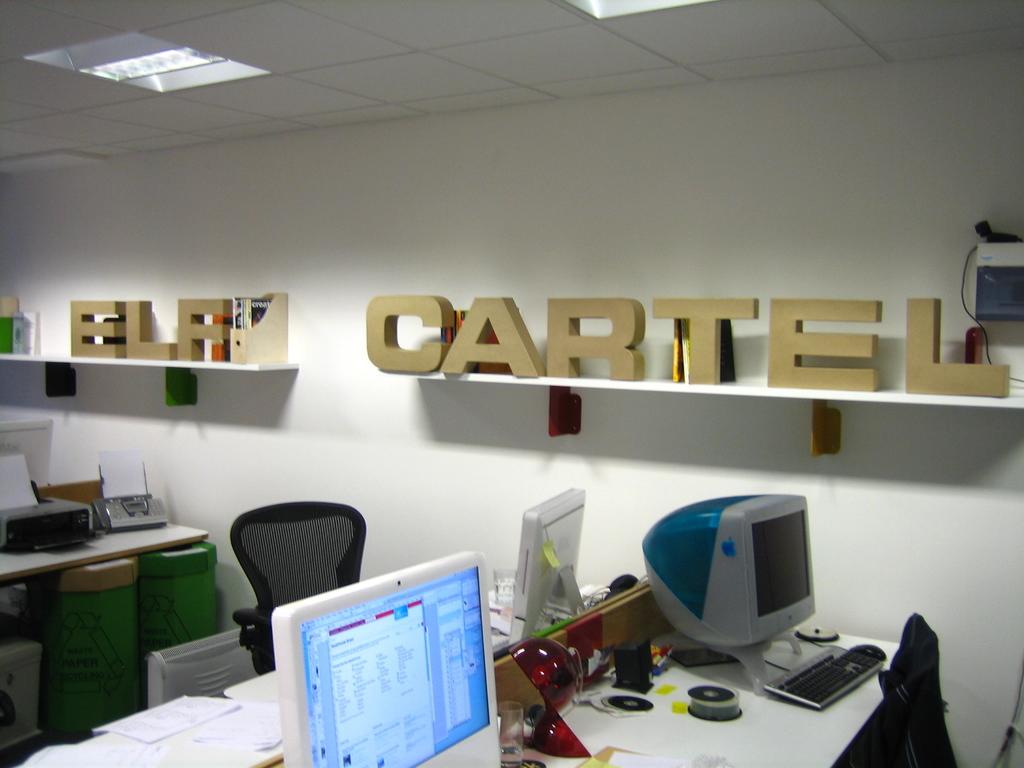What is the name of the company?
Offer a very short reply. Elf cartel. What word is on the shelf to the left?
Your response must be concise. Elf. 